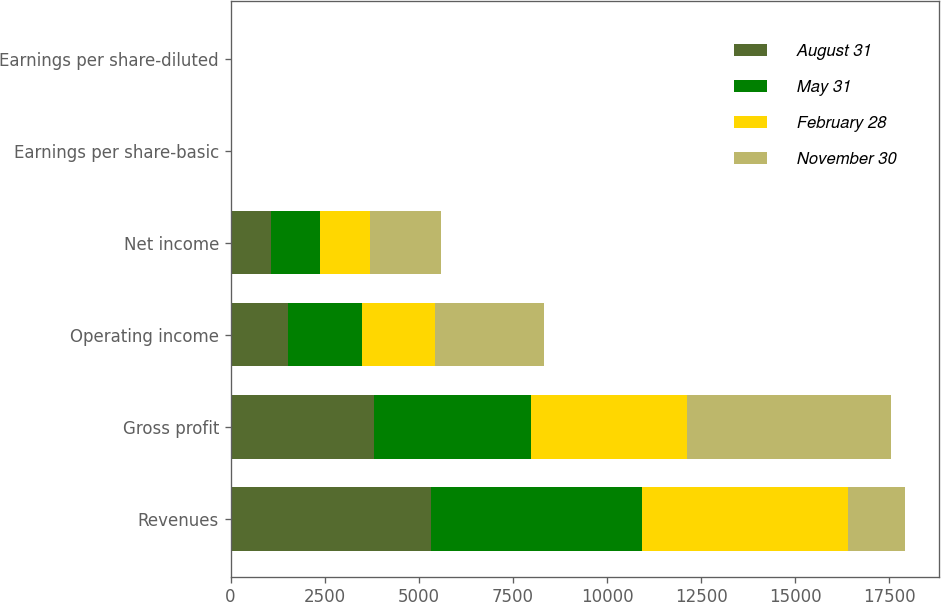Convert chart to OTSL. <chart><loc_0><loc_0><loc_500><loc_500><stacked_bar_chart><ecel><fcel>Revenues<fcel>Gross profit<fcel>Operating income<fcel>Net income<fcel>Earnings per share-basic<fcel>Earnings per share-diluted<nl><fcel>August 31<fcel>5331<fcel>3805<fcel>1521<fcel>1077<fcel>0.21<fcel>0.21<nl><fcel>May 31<fcel>5607<fcel>4185<fcel>1975<fcel>1296<fcel>0.25<fcel>0.25<nl><fcel>February 28<fcel>5453<fcel>4119<fcel>1940<fcel>1329<fcel>0.27<fcel>0.26<nl><fcel>November 30<fcel>1521<fcel>5441<fcel>2884<fcel>1891<fcel>0.38<fcel>0.38<nl></chart> 